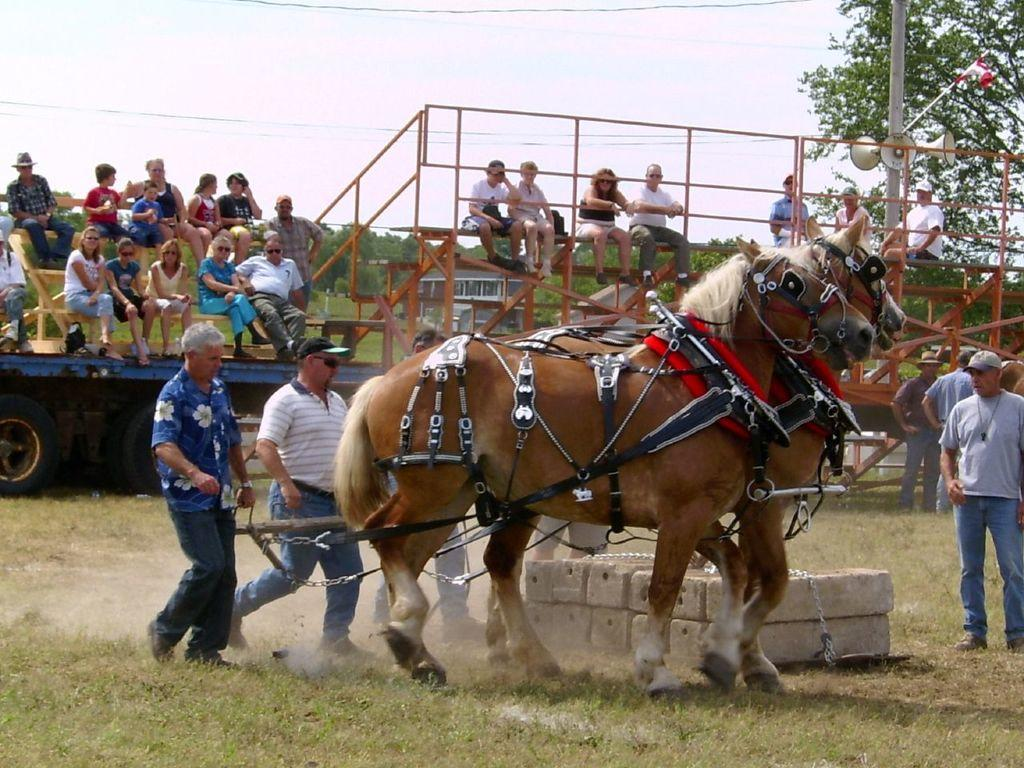How many horses are in the image? There are 2 horses in the image. What other subjects are present in the image besides the horses? There are men and people sitting in the background of the image. What can be seen in the background of the image? There is a pole, trees, and the sky visible in the background of the image. What type of disease is affecting the horses in the image? There is no indication of any disease affecting the horses in the image. Can you see any laborers working in the image? There is no mention of laborers in the image; it only features horses, men, people sitting, a pole, trees, and the sky. 